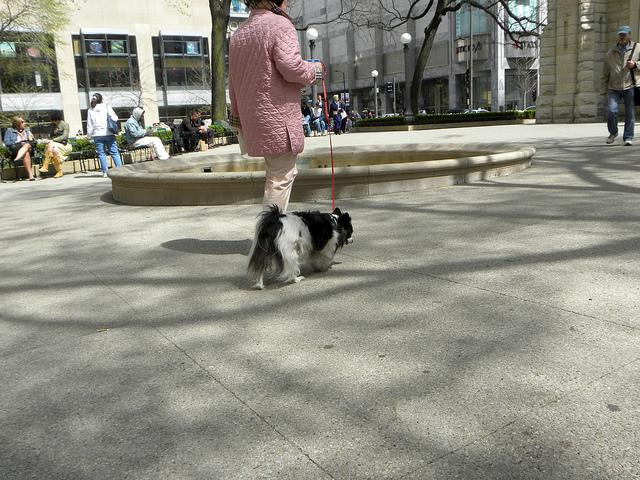What color is the leash?
Short answer required. Red. Is the dog furry?
Short answer required. Yes. Is the dog running?
Keep it brief. No. What color is the dog?
Write a very short answer. Black and white. 